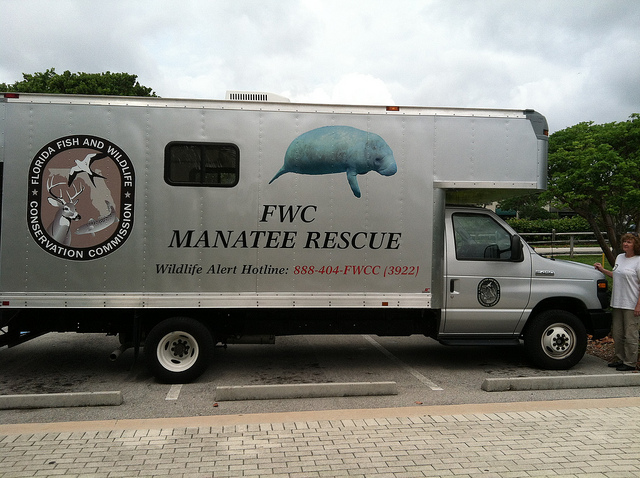Extract all visible text content from this image. FWC MANATEE RESCUE Wildlife Hotline FLORIDA CONSERVATION COMMISSION WILDLIFE AND FISH 3922 888-404-FWCCC Alert 